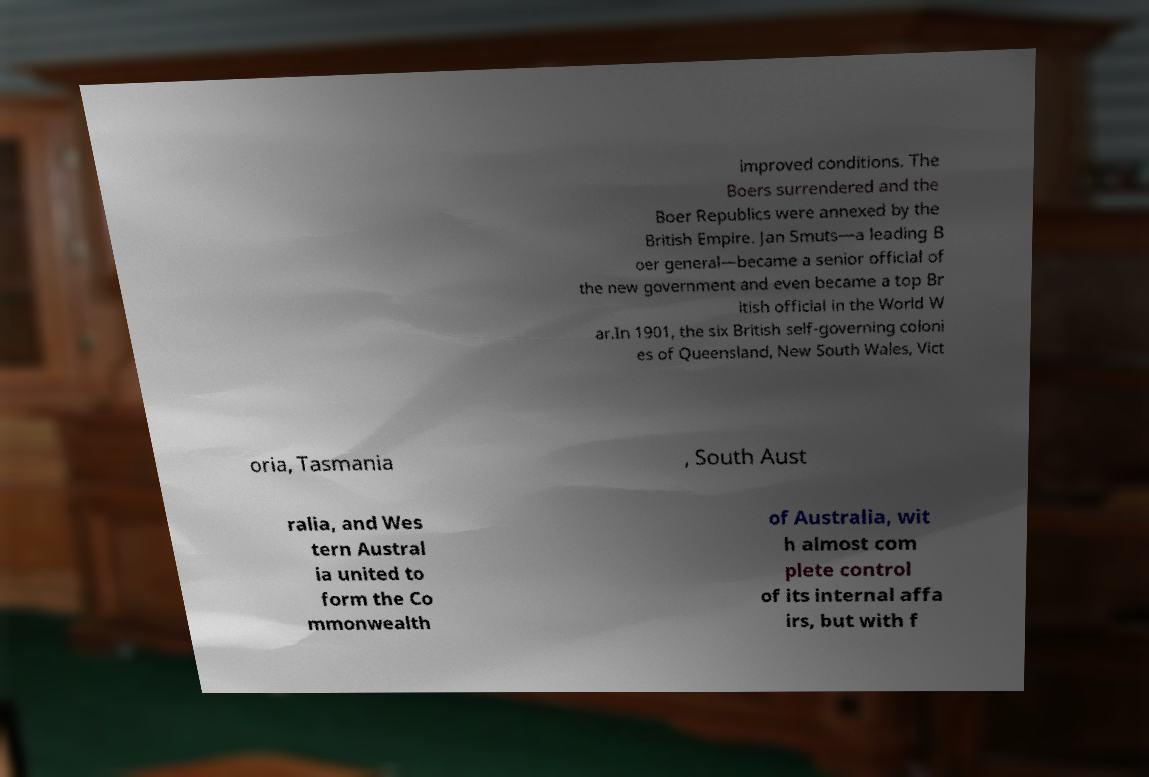I need the written content from this picture converted into text. Can you do that? improved conditions. The Boers surrendered and the Boer Republics were annexed by the British Empire. Jan Smuts—a leading B oer general—became a senior official of the new government and even became a top Br itish official in the World W ar.In 1901, the six British self-governing coloni es of Queensland, New South Wales, Vict oria, Tasmania , South Aust ralia, and Wes tern Austral ia united to form the Co mmonwealth of Australia, wit h almost com plete control of its internal affa irs, but with f 